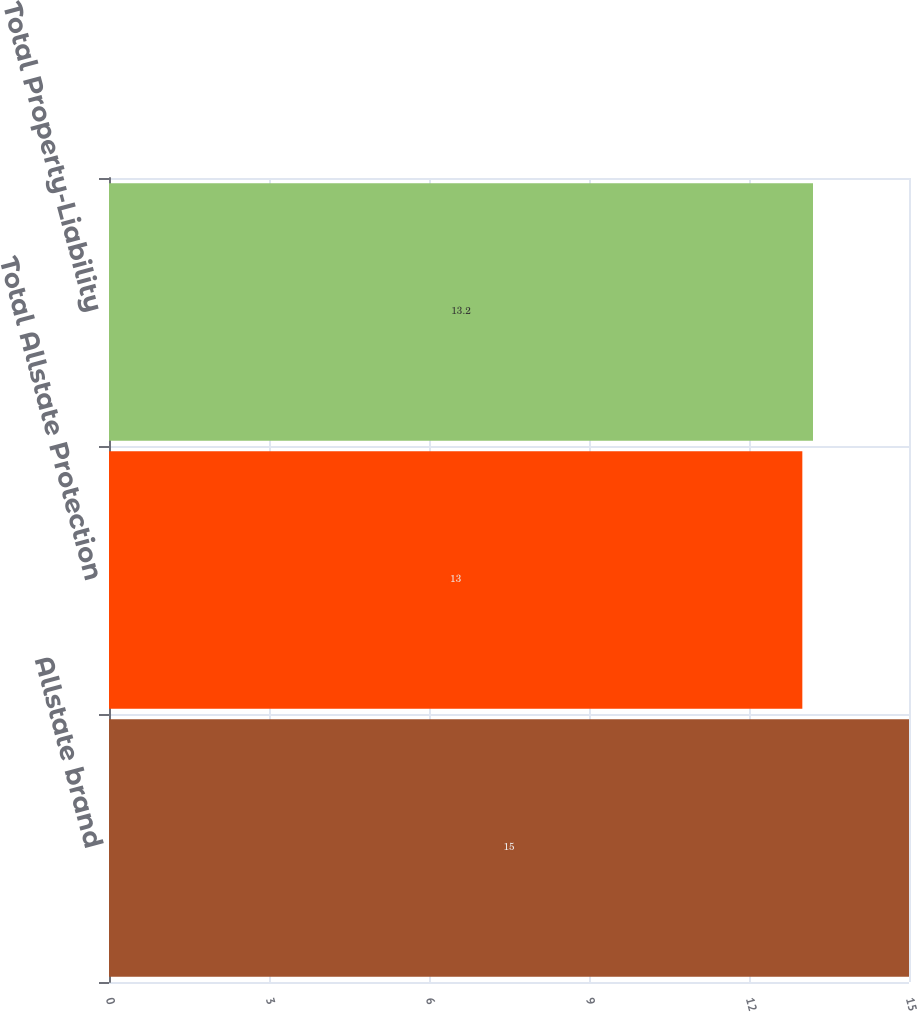Convert chart to OTSL. <chart><loc_0><loc_0><loc_500><loc_500><bar_chart><fcel>Allstate brand<fcel>Total Allstate Protection<fcel>Total Property-Liability<nl><fcel>15<fcel>13<fcel>13.2<nl></chart> 